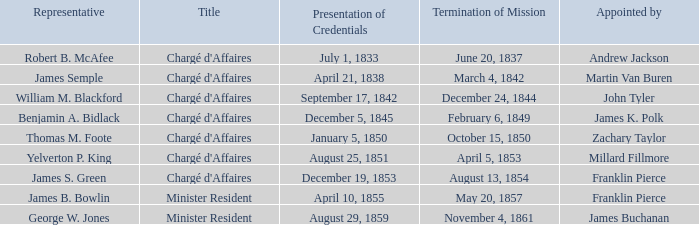What's the emissary listed who has a presentation of credentials for august 25, 1851? Yelverton P. King. 